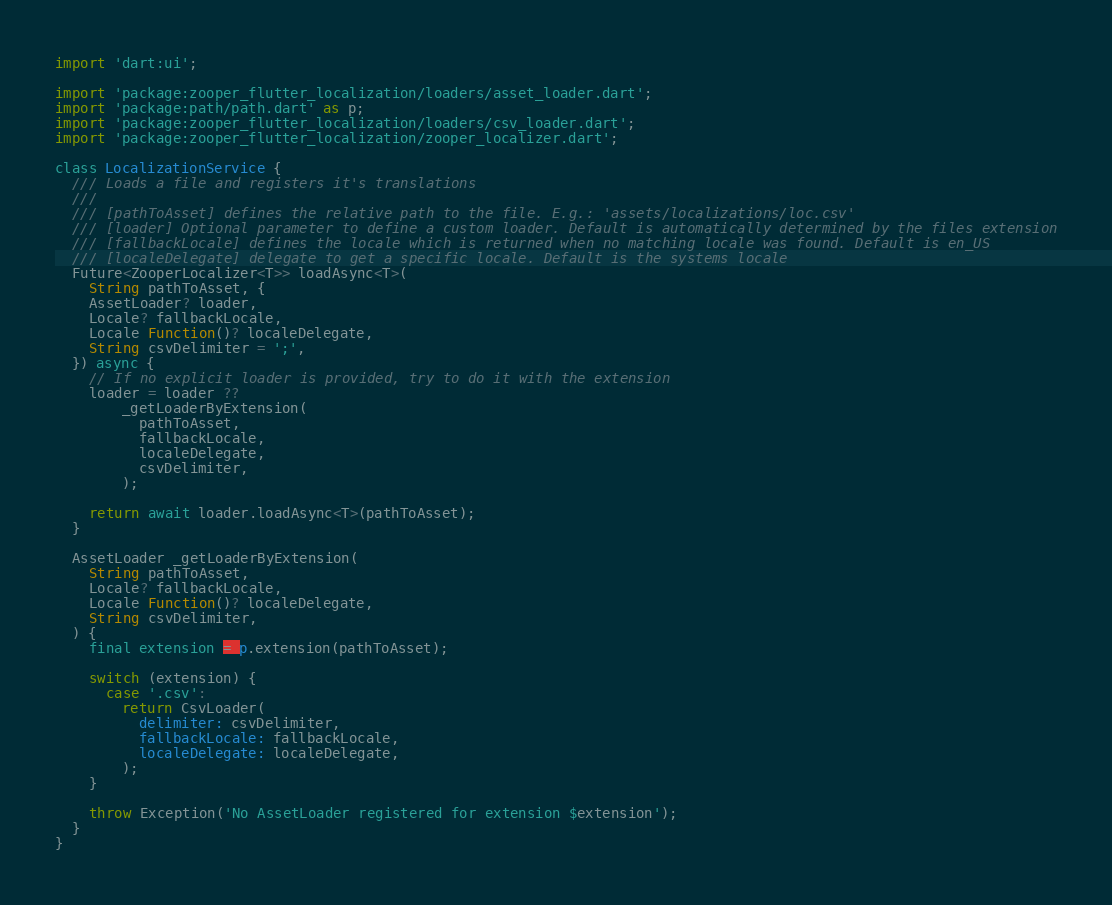Convert code to text. <code><loc_0><loc_0><loc_500><loc_500><_Dart_>import 'dart:ui';

import 'package:zooper_flutter_localization/loaders/asset_loader.dart';
import 'package:path/path.dart' as p;
import 'package:zooper_flutter_localization/loaders/csv_loader.dart';
import 'package:zooper_flutter_localization/zooper_localizer.dart';

class LocalizationService {
  /// Loads a file and registers it's translations
  ///
  /// [pathToAsset] defines the relative path to the file. E.g.: 'assets/localizations/loc.csv'
  /// [loader] Optional parameter to define a custom loader. Default is automatically determined by the files extension
  /// [fallbackLocale] defines the locale which is returned when no matching locale was found. Default is en_US
  /// [localeDelegate] delegate to get a specific locale. Default is the systems locale
  Future<ZooperLocalizer<T>> loadAsync<T>(
    String pathToAsset, {
    AssetLoader? loader,
    Locale? fallbackLocale,
    Locale Function()? localeDelegate,
    String csvDelimiter = ';',
  }) async {
    // If no explicit loader is provided, try to do it with the extension
    loader = loader ??
        _getLoaderByExtension(
          pathToAsset,
          fallbackLocale,
          localeDelegate,
          csvDelimiter,
        );

    return await loader.loadAsync<T>(pathToAsset);
  }

  AssetLoader _getLoaderByExtension(
    String pathToAsset,
    Locale? fallbackLocale,
    Locale Function()? localeDelegate,
    String csvDelimiter,
  ) {
    final extension = p.extension(pathToAsset);

    switch (extension) {
      case '.csv':
        return CsvLoader(
          delimiter: csvDelimiter,
          fallbackLocale: fallbackLocale,
          localeDelegate: localeDelegate,
        );
    }

    throw Exception('No AssetLoader registered for extension $extension');
  }
}
</code> 